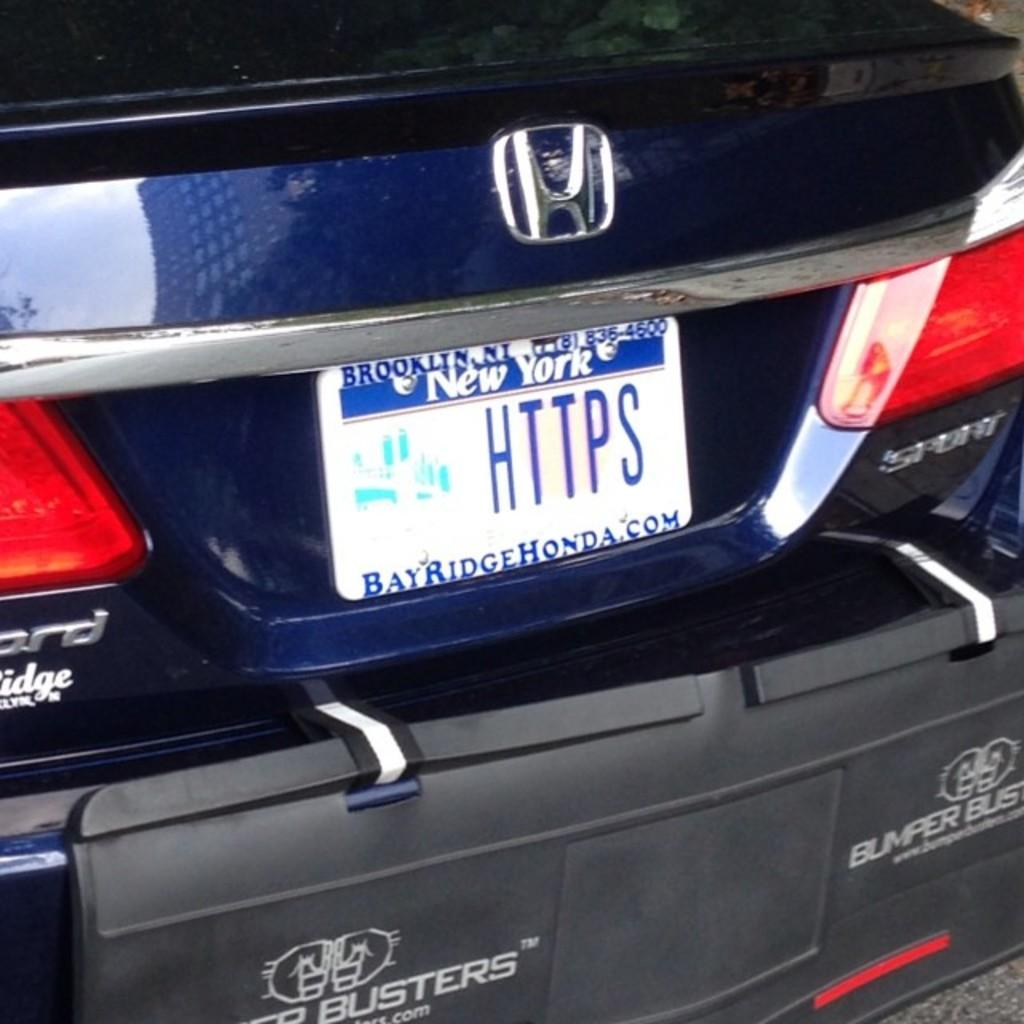<image>
Give a short and clear explanation of the subsequent image. New York license plate that says HTTPS on it. 